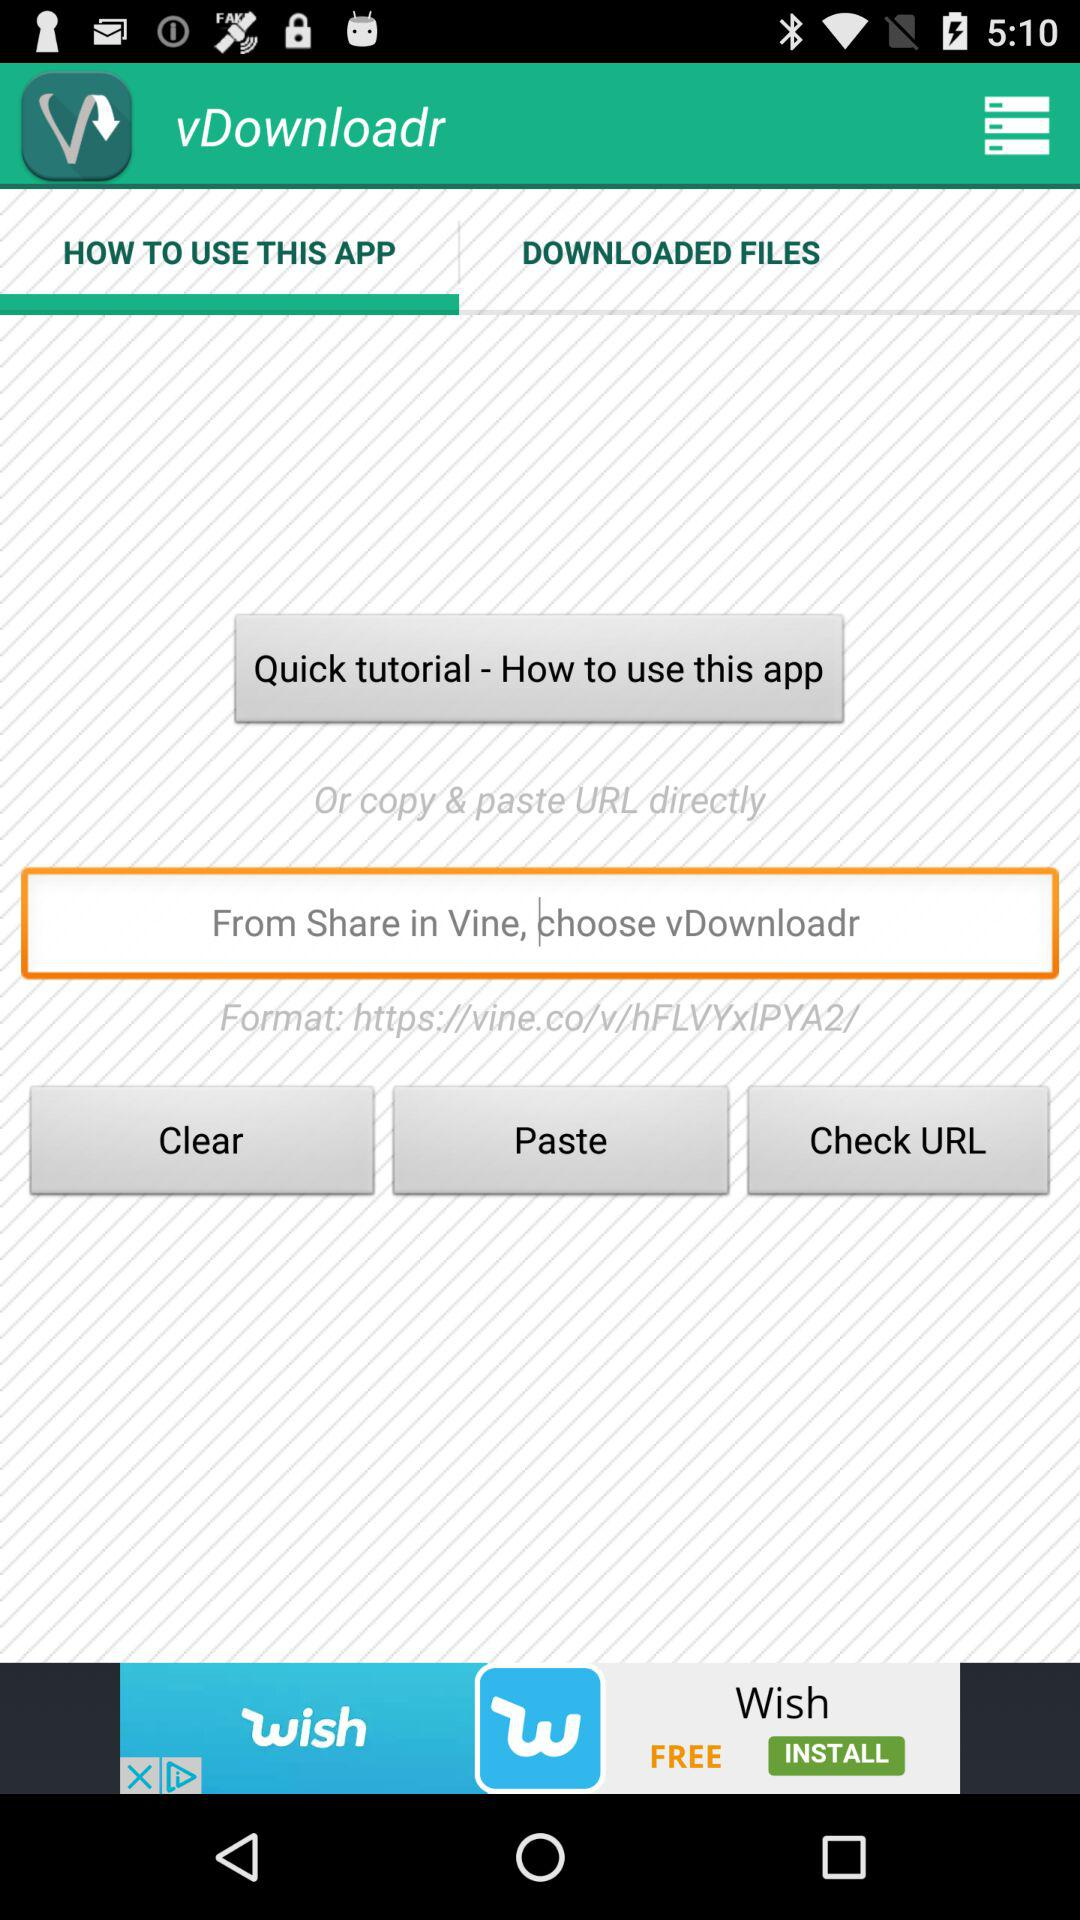What option is selected in vDownloadr tab? The selected option is "HOW TO USE THIS APP". 